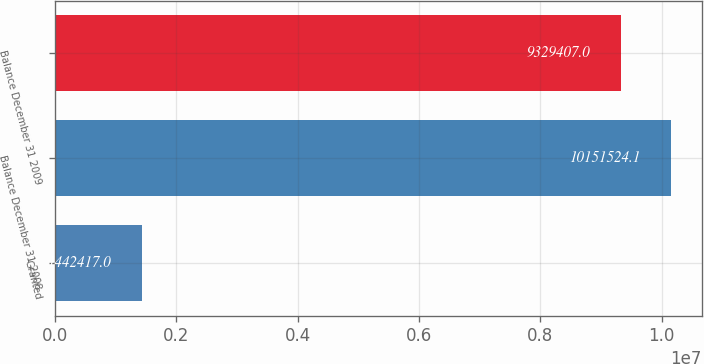<chart> <loc_0><loc_0><loc_500><loc_500><bar_chart><fcel>Granted<fcel>Balance December 31 2008<fcel>Balance December 31 2009<nl><fcel>1.44242e+06<fcel>1.01515e+07<fcel>9.32941e+06<nl></chart> 